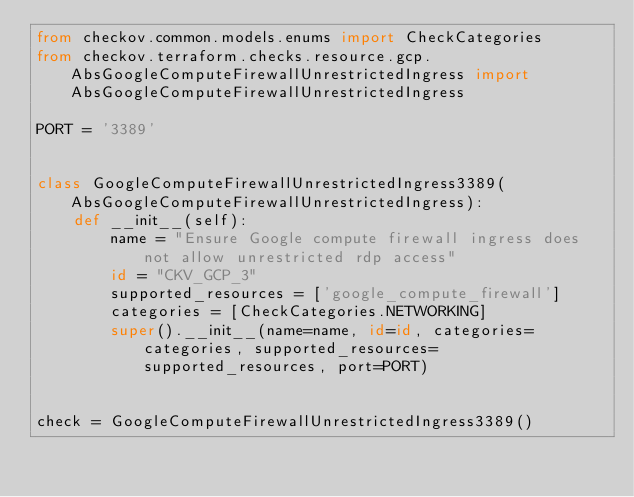Convert code to text. <code><loc_0><loc_0><loc_500><loc_500><_Python_>from checkov.common.models.enums import CheckCategories
from checkov.terraform.checks.resource.gcp.AbsGoogleComputeFirewallUnrestrictedIngress import AbsGoogleComputeFirewallUnrestrictedIngress

PORT = '3389'


class GoogleComputeFirewallUnrestrictedIngress3389(AbsGoogleComputeFirewallUnrestrictedIngress):
    def __init__(self):
        name = "Ensure Google compute firewall ingress does not allow unrestricted rdp access"
        id = "CKV_GCP_3"
        supported_resources = ['google_compute_firewall']
        categories = [CheckCategories.NETWORKING]
        super().__init__(name=name, id=id, categories=categories, supported_resources=supported_resources, port=PORT)


check = GoogleComputeFirewallUnrestrictedIngress3389()
</code> 